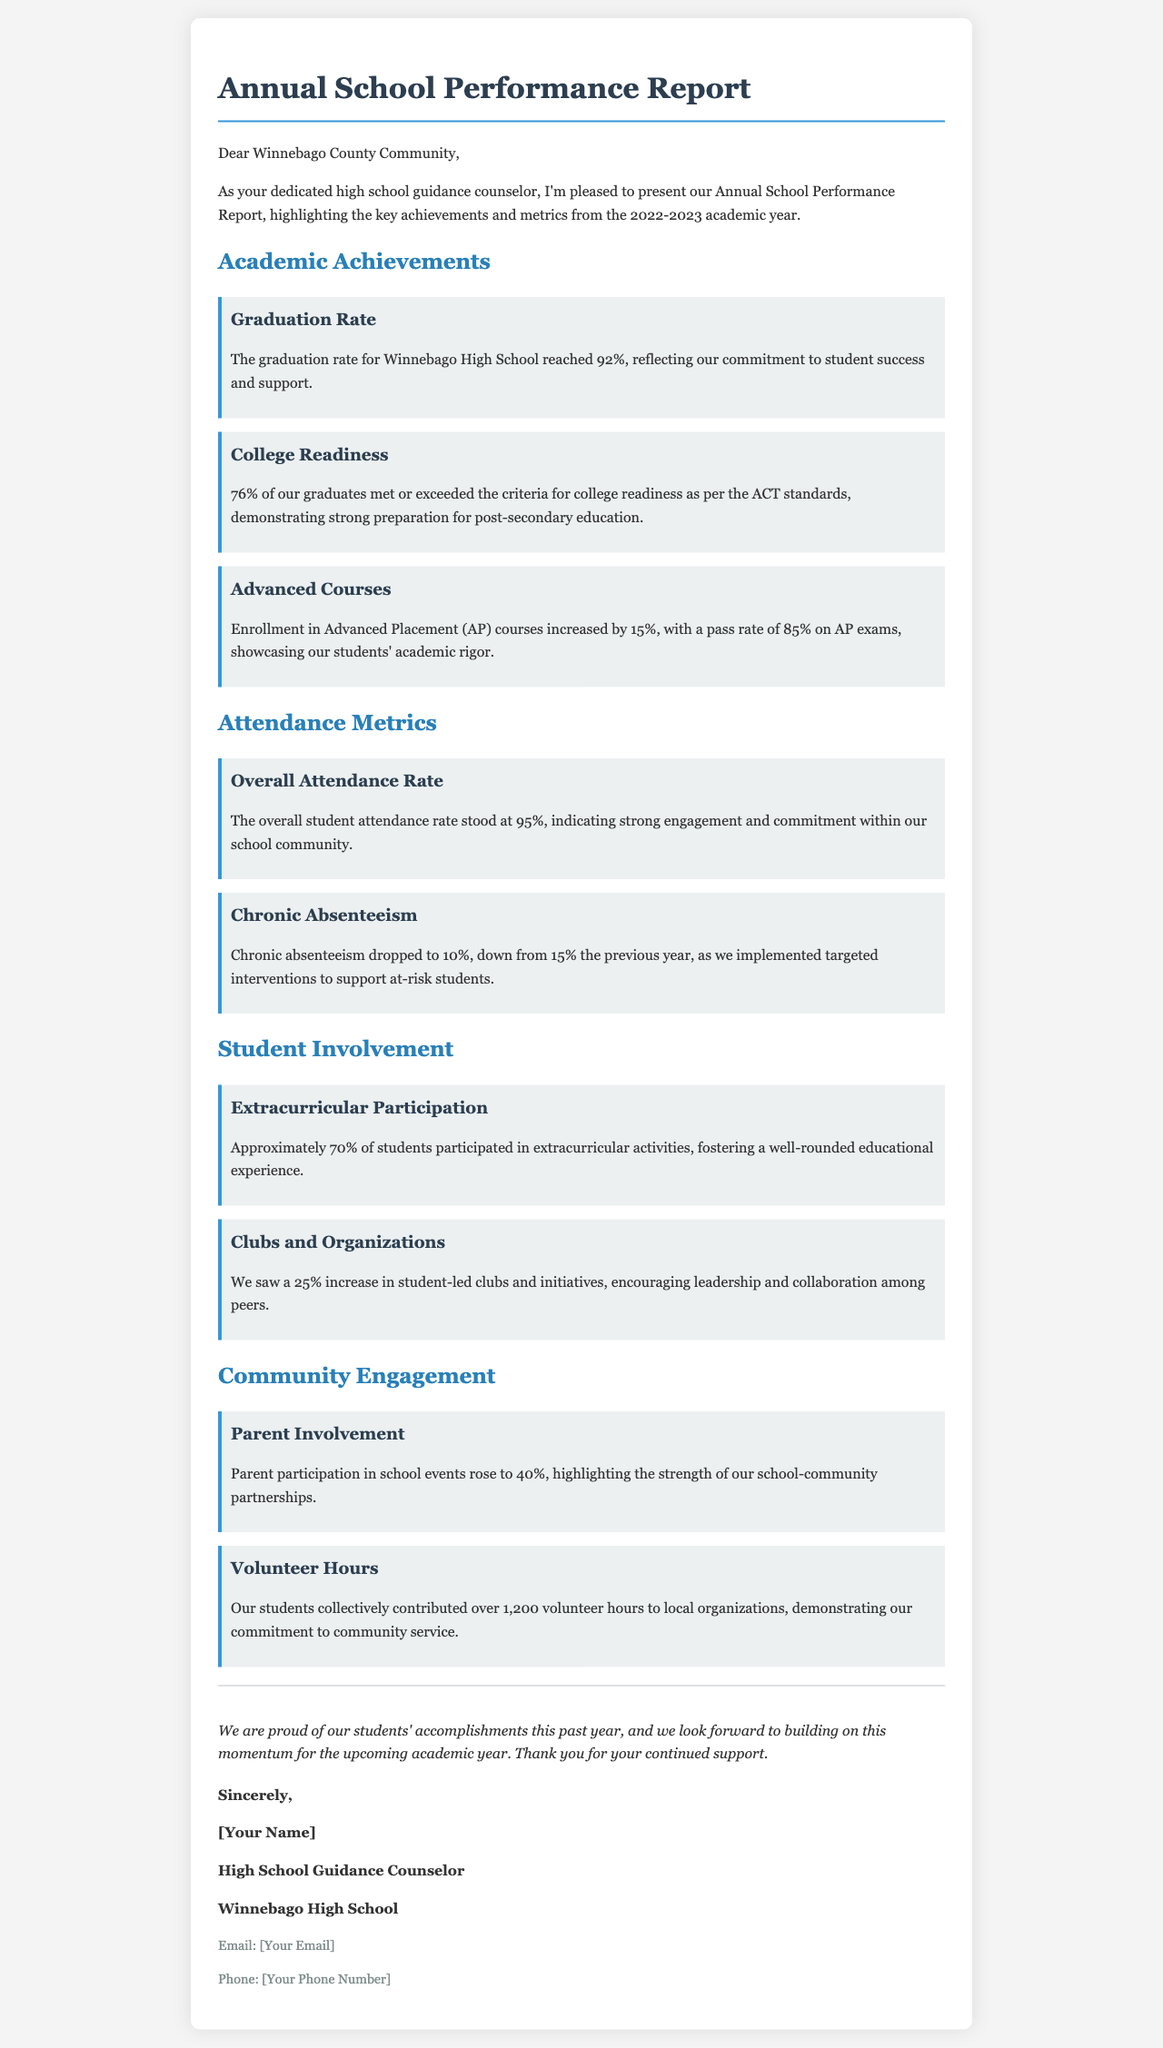What is the graduation rate for Winnebago High School? The graduation rate mentioned in the document is a specific statistic highlighted under Academic Achievements.
Answer: 92% What percentage of graduates met the college readiness criteria? This percentage is noted in the College Readiness section and gives insight into academic performance relative to college preparation.
Answer: 76% What was the increase in enrollment for Advanced Placement courses? The document specifies this change as a percentage, reflecting growth in academic rigor.
Answer: 15% What does the overall attendance rate stand at? The overall attendance rate is a key metric that indicates student engagement and is clearly stated in the Attendance Metrics section.
Answer: 95% What is the chronic absenteeism rate reported? This statistic provides insight into school attendance challenges and is compared with the previous year's data in the report.
Answer: 10% How many hours did students contribute to community service? This figure showcases the involvement of students in community initiatives, found under the Community Engagement section.
Answer: 1,200 What percentage of students participated in extracurricular activities? This statistic indicates the level of student engagement in non-academic pursuits, found in the Student Involvement section.
Answer: 70% What was the increase in parent participation in school events? This percentage reflects the growth of community involvement and engagement, underscoring school-community relationships.
Answer: 40% How much did student-led clubs and initiatives increase by? This question refers to a specific growth metric in student involvement, demonstrating leadership opportunities.
Answer: 25% 